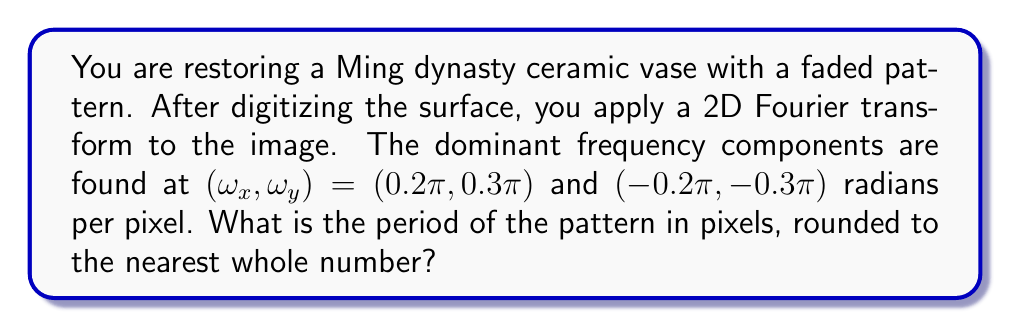What is the answer to this math problem? To solve this problem, we need to understand the relationship between frequency components in the Fourier domain and spatial patterns in the image domain. Let's approach this step-by-step:

1) The Fourier transform reveals frequency components in both x and y directions. The dominant frequencies are:
   $(\omega_x, \omega_y) = (0.2\pi, 0.3\pi)$ and $(-0.2\pi, -0.3\pi)$ radians per pixel

2) These frequencies are symmetric around the origin, which is typical for real-valued images. We'll focus on the positive frequencies.

3) The relationship between frequency $\omega$ (in radians per pixel) and period $T$ (in pixels) is:

   $$T = \frac{2\pi}{\omega}$$

4) For the x-direction:
   $$T_x = \frac{2\pi}{0.2\pi} = 10 \text{ pixels}$$

5) For the y-direction:
   $$T_y = \frac{2\pi}{0.3\pi} = \frac{20}{3} \approx 6.67 \text{ pixels}$$

6) The overall period of the pattern is determined by both x and y components. We can calculate this using the Pythagorean theorem:

   $$T = \sqrt{T_x^2 + T_y^2} = \sqrt{10^2 + (\frac{20}{3})^2} \approx 12.06 \text{ pixels}$$

7) Rounding to the nearest whole number: 12 pixels

This period represents the spatial repetition of the dominant pattern on the ceramic vase surface.
Answer: 12 pixels 